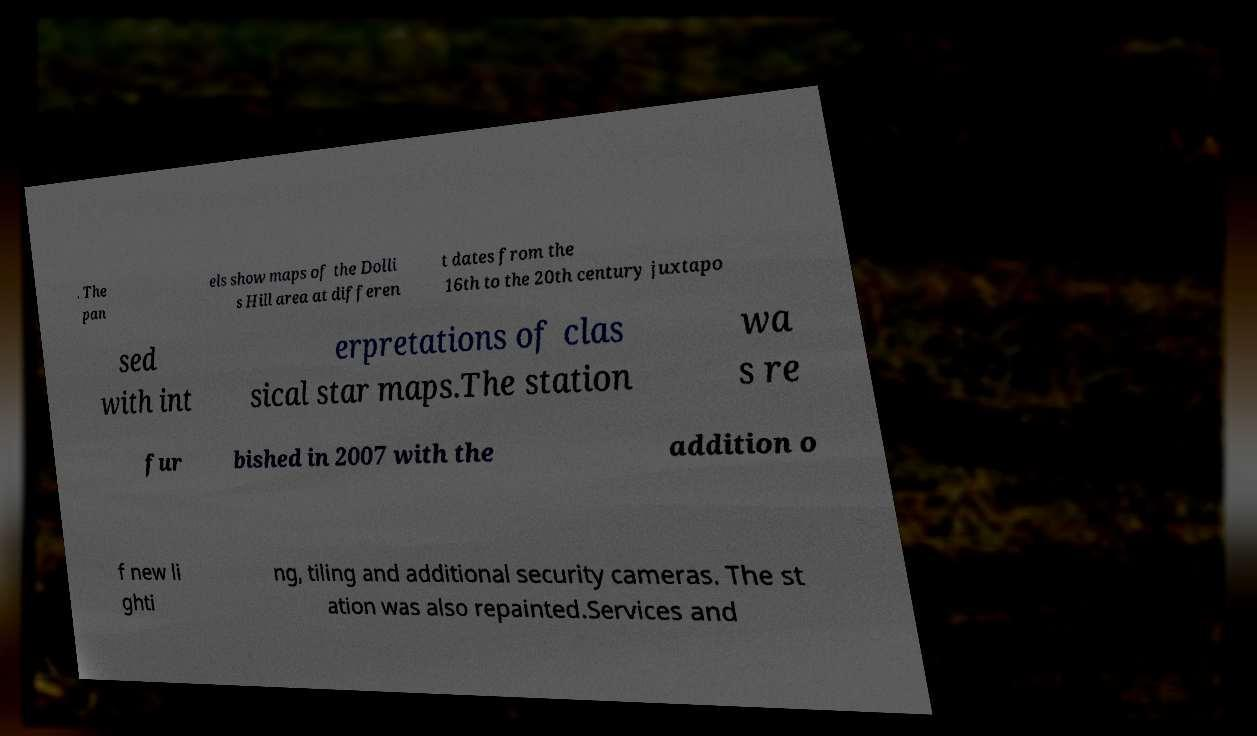For documentation purposes, I need the text within this image transcribed. Could you provide that? . The pan els show maps of the Dolli s Hill area at differen t dates from the 16th to the 20th century juxtapo sed with int erpretations of clas sical star maps.The station wa s re fur bished in 2007 with the addition o f new li ghti ng, tiling and additional security cameras. The st ation was also repainted.Services and 